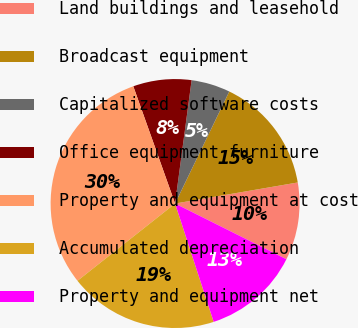Convert chart. <chart><loc_0><loc_0><loc_500><loc_500><pie_chart><fcel>Land buildings and leasehold<fcel>Broadcast equipment<fcel>Capitalized software costs<fcel>Office equipment furniture<fcel>Property and equipment at cost<fcel>Accumulated depreciation<fcel>Property and equipment net<nl><fcel>10.09%<fcel>15.12%<fcel>5.05%<fcel>7.57%<fcel>30.21%<fcel>19.36%<fcel>12.6%<nl></chart> 